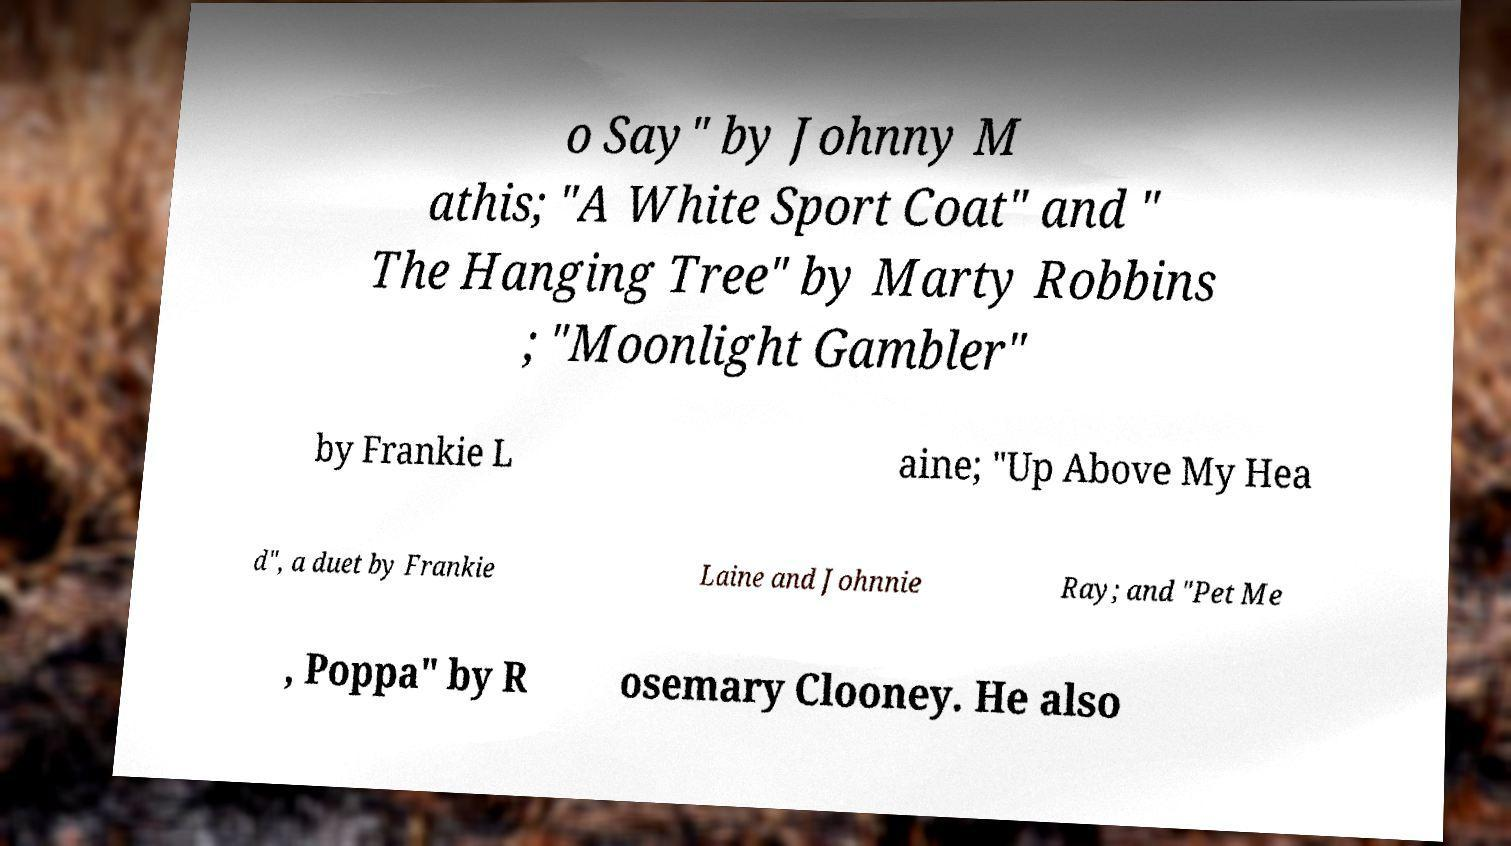Could you extract and type out the text from this image? o Say" by Johnny M athis; "A White Sport Coat" and " The Hanging Tree" by Marty Robbins ; "Moonlight Gambler" by Frankie L aine; "Up Above My Hea d", a duet by Frankie Laine and Johnnie Ray; and "Pet Me , Poppa" by R osemary Clooney. He also 